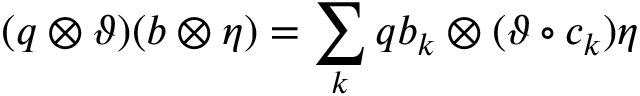<formula> <loc_0><loc_0><loc_500><loc_500>( q \otimes \vartheta ) ( b \otimes \eta ) = \sum _ { k } q b _ { k } \otimes ( \vartheta \circ c _ { k } ) \eta</formula> 